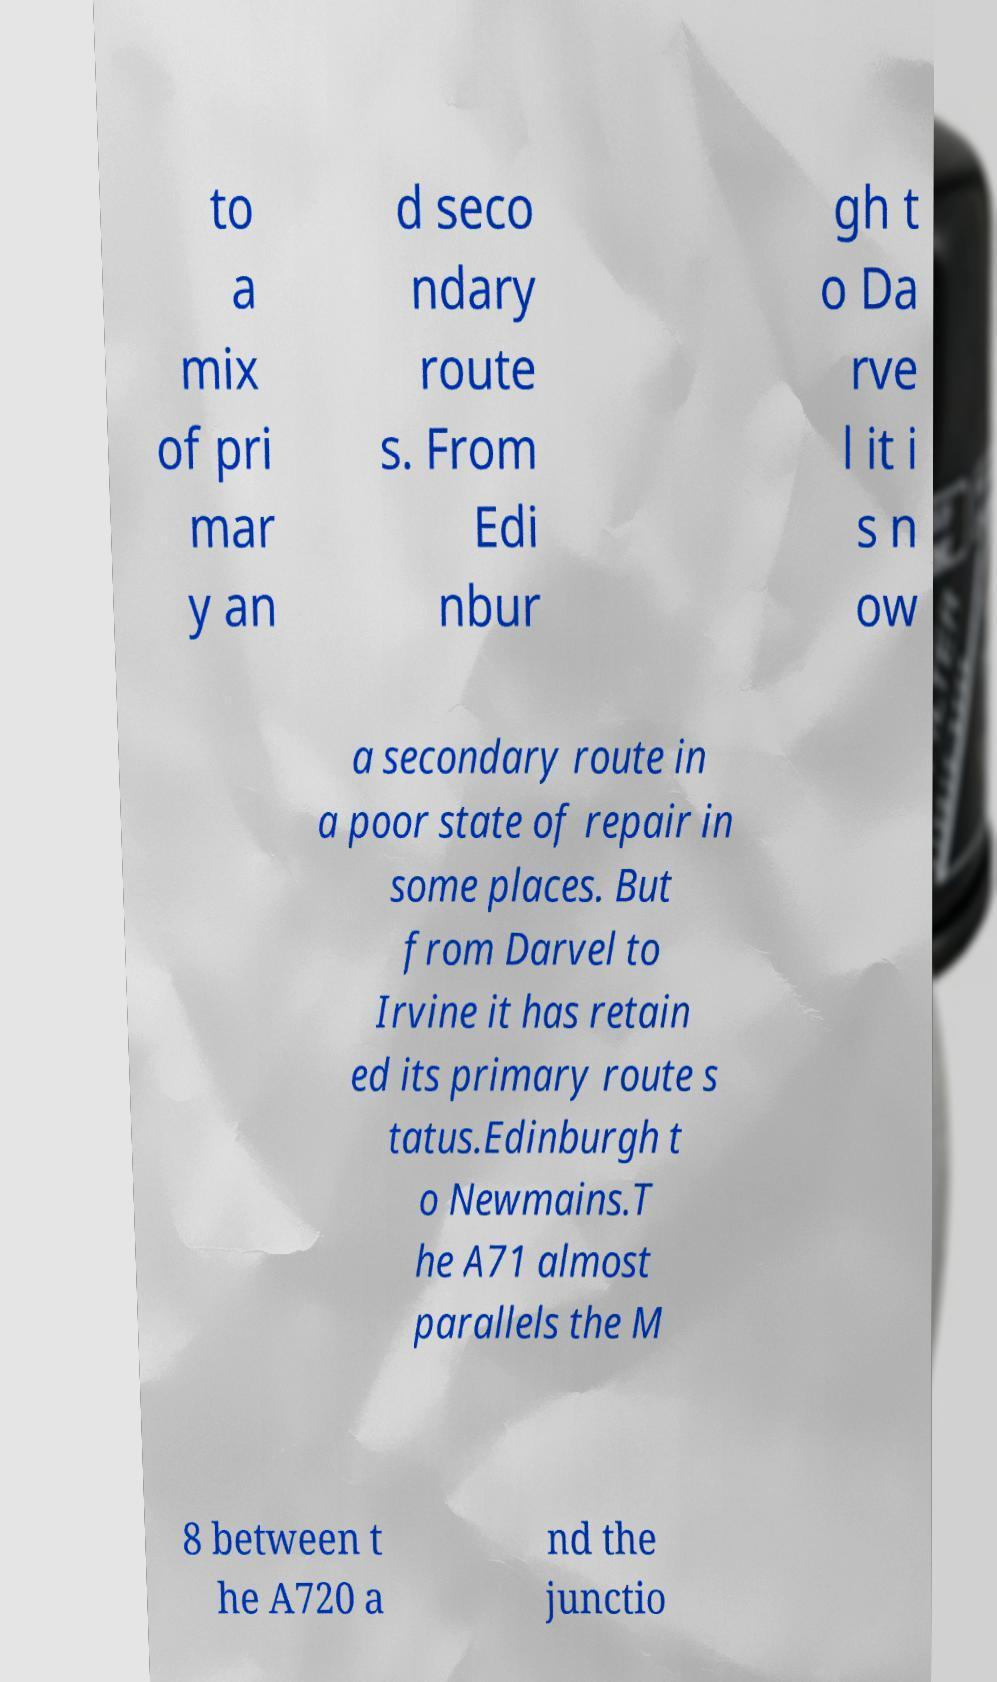Please read and relay the text visible in this image. What does it say? to a mix of pri mar y an d seco ndary route s. From Edi nbur gh t o Da rve l it i s n ow a secondary route in a poor state of repair in some places. But from Darvel to Irvine it has retain ed its primary route s tatus.Edinburgh t o Newmains.T he A71 almost parallels the M 8 between t he A720 a nd the junctio 